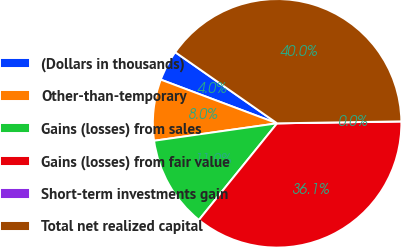<chart> <loc_0><loc_0><loc_500><loc_500><pie_chart><fcel>(Dollars in thousands)<fcel>Other-than-temporary<fcel>Gains (losses) from sales<fcel>Gains (losses) from fair value<fcel>Short-term investments gain<fcel>Total net realized capital<nl><fcel>3.98%<fcel>7.96%<fcel>11.93%<fcel>36.08%<fcel>0.0%<fcel>40.05%<nl></chart> 